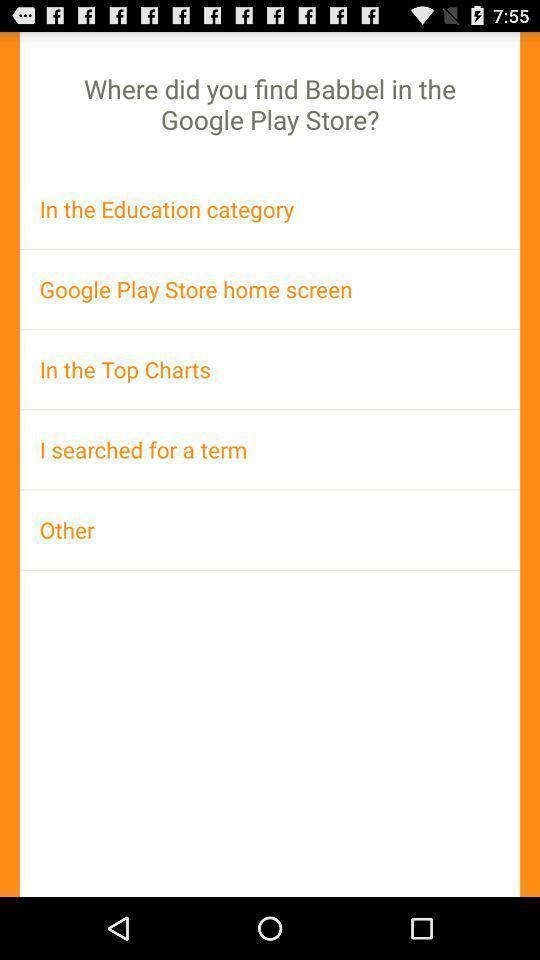Give me a narrative description of this picture. Screen showing various categories where do we found the app. 